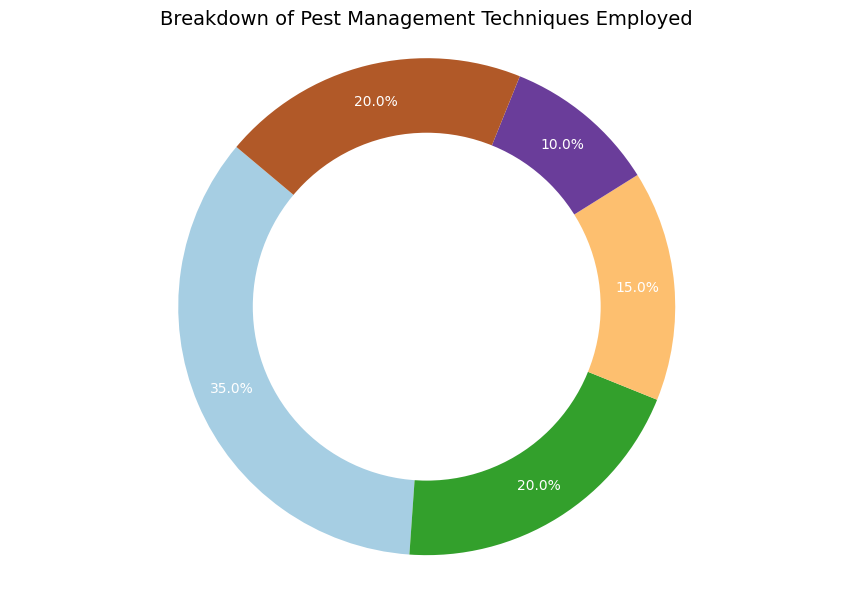Which pest management technique has the highest usage frequency? The segment representing Chemical Pesticides appears to cover the largest area of the pie chart and the percentage is marked as 35%, indicating it has the highest usage frequency.
Answer: Chemical Pesticides Which two techniques have an equal percentage of usage? The labels indicate that both Biological Control and Integrated Pest Management have a usage frequency of 20%, meaning they are equal.
Answer: Biological Control and Integrated Pest Management What is the combined usage frequency of Mechanical Methods and Cultural Practices? Mechanical Methods are marked as 10% and Cultural Practices are marked as 15%. Adding these percentages together: 10% + 15% = 25%.
Answer: 25% How does the usage frequency of Cultural Practices compare to Biological Control? Cultural Practices are marked as 15% and Biological Control as 20%. Comparing these values, 15% is less than 20%.
Answer: Cultural Practices have a lower usage frequency Which pest management technique is visually represented with the smallest segment? The smallest segment on the pie chart is for Mechanical Methods, marked with a usage frequency of 10%.
Answer: Mechanical Methods Is the sum of the usage frequencies of Biological Control and Integrated Pest Management higher than Chemical Pesticides? Biological Control and Integrated Pest Management each have a usage frequency of 20%, totaling 40% (20% + 20%). Chemical Pesticides have a usage frequency of 35%. Since 40% > 35%, the sum is higher.
Answer: Yes What is the difference in the usage frequency between Cultural Practices and Mechanical Methods? Cultural Practices are marked as 15% and Mechanical Methods as 10%. The difference is calculated as 15% - 10% = 5%.
Answer: 5% Which technique has the second highest usage frequency? The frequencies are as follows: Chemical Pesticides (35%), Biological Control (20%), Integrated Pest Management (20%), Cultural Practices (15%), Mechanical Methods (10%). The second highest percentages are tied at 20% for Biological Control and Integrated Pest Management.
Answer: Biological Control and Integrated Pest Management 